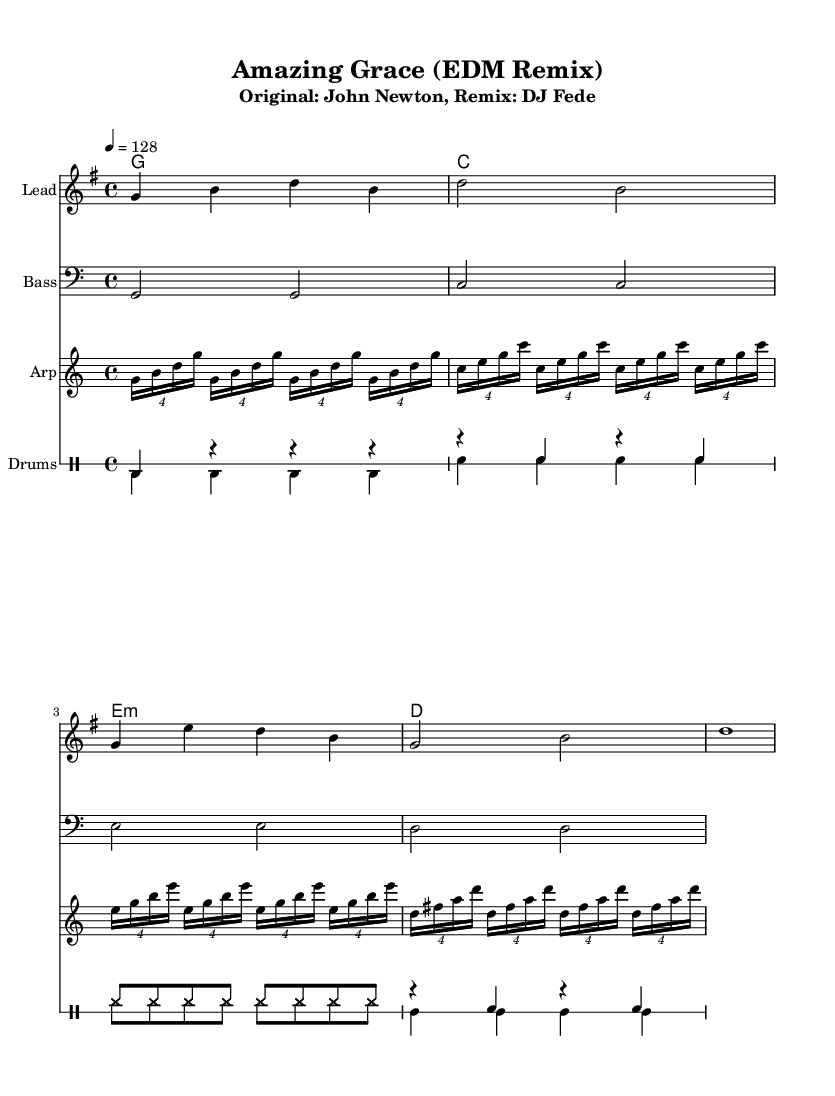What is the key signature of this music? The key signature is G major, indicated by one sharp (F#), shown at the beginning of the staff.
Answer: G major What is the time signature of this piece? The time signature is 4/4, which means there are four beats in each measure, and it is indicated numerically at the start of the piece.
Answer: 4/4 What tempo is indicated for this song? The tempo is marked as 128 beats per minute, specified in the tempo marking.
Answer: 128 How many measures are in the melody section? The melody section consists of six measures, counted from the beginning until the last note before the next section starts.
Answer: 6 Which type of drums are used in the remix? The remix utilizes bass drum, snare drum, hi-hat, and clap, indicated by the specific notations in the drum part.
Answer: Bass drum, snare drum, hi-hat, clap What type of electronic instrument does the arpeggiator mimic? The arpeggiator mimics a synthesizer, as it plays rapid repeated notes typical in electronic music styles.
Answer: Synthesizer Which chord appears most frequently in the harmony section? The chord G major appears most frequently, as it is notated at the beginning of each repeated cycle in the harmony section.
Answer: G major 